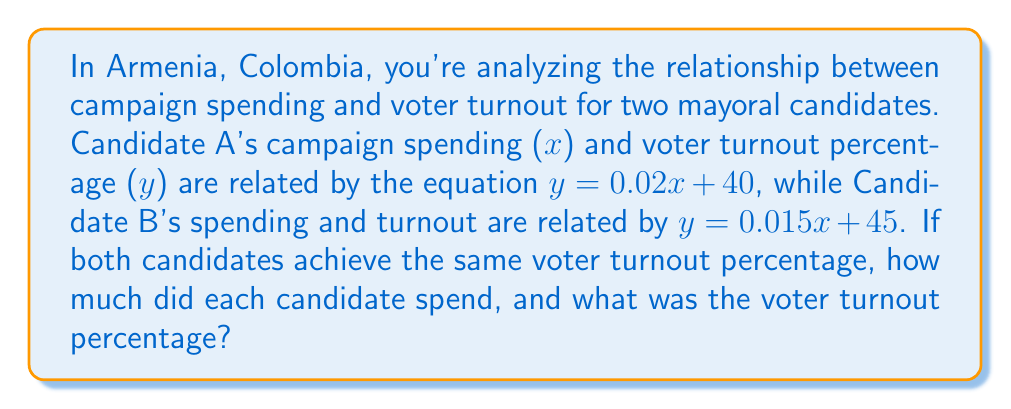Can you solve this math problem? To solve this problem, we need to find the point where the two equations intersect. This represents the point where both candidates have the same voter turnout percentage for their respective campaign spending.

Let's set up the system of equations:

$$\begin{cases}
y = 0.02x + 40 & \text{(Candidate A)}\\
y = 0.015x + 45 & \text{(Candidate B)}
\end{cases}$$

Since we're looking for the point where the voter turnout is the same for both candidates, we can set these equations equal to each other:

$$0.02x + 40 = 0.015x + 45$$

Now, let's solve for $x$:

1) Subtract 40 from both sides:
   $$0.02x = 0.015x + 5$$

2) Subtract 0.015x from both sides:
   $$0.005x = 5$$

3) Divide both sides by 0.005:
   $$x = 1000$$

So, Candidate A spent $1000 (in thousands of pesos or the relevant currency).

To find Candidate B's spending, we can substitute this $x$ value into either of the original equations. Let's use Candidate A's equation:

$$y = 0.02(1000) + 40 = 20 + 40 = 60$$

Therefore, the voter turnout percentage for both candidates is 60%.

To verify Candidate B's spending, we can substitute these values into B's equation:

$$60 = 0.015x + 45$$
$$15 = 0.015x$$
$$x = 1000$$

This confirms that Candidate B also spent $1000 (in thousands of pesos or the relevant currency).
Answer: Each candidate spent $1000 (in thousands of pesos or the relevant currency), and the voter turnout percentage was 60%. 